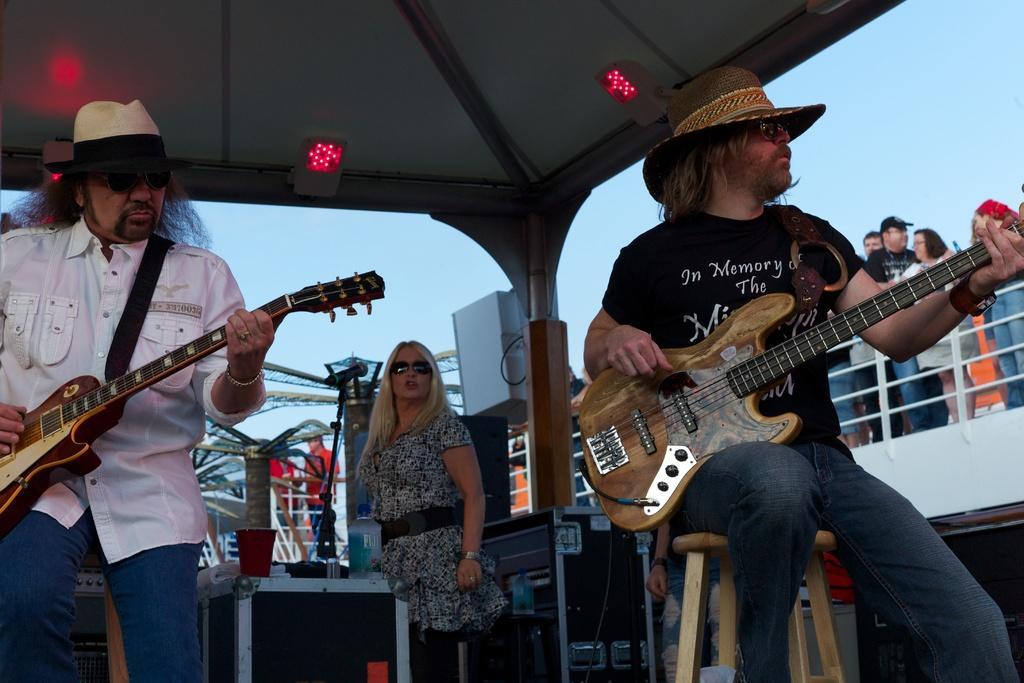In one or two sentences, can you explain what this image depicts? In this picture we can see two men and one woman where this two are sitting on stools and holding guitars in their hands and playing it and in background we can see some persons standing at fence this woman wore goggles and in front of her we have bottle on speakers, shed. 